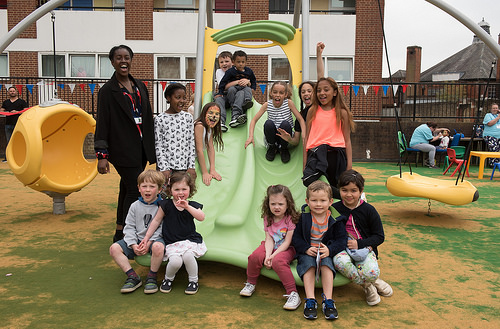<image>
Can you confirm if the child is on the slide? Yes. Looking at the image, I can see the child is positioned on top of the slide, with the slide providing support. Is there a boy to the left of the girl? No. The boy is not to the left of the girl. From this viewpoint, they have a different horizontal relationship. Is there a girl to the right of the slide? No. The girl is not to the right of the slide. The horizontal positioning shows a different relationship. Where is the kids in relation to the park? Is it in the park? Yes. The kids is contained within or inside the park, showing a containment relationship. 